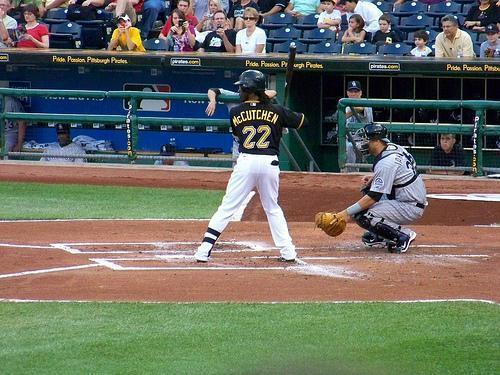How many hitters are shown?
Give a very brief answer. 1. How many people are playing football?
Give a very brief answer. 0. How many people are wearing white pants?
Give a very brief answer. 1. 